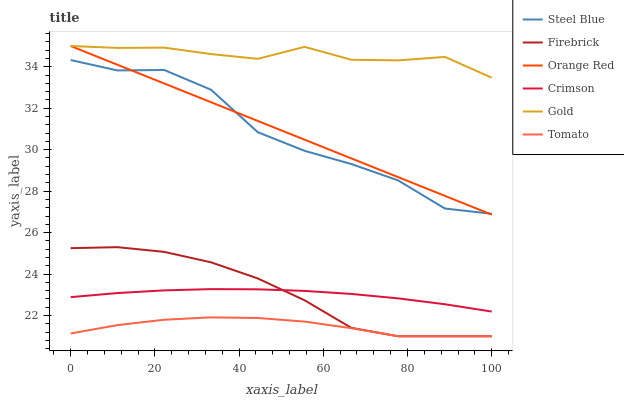Does Firebrick have the minimum area under the curve?
Answer yes or no. No. Does Firebrick have the maximum area under the curve?
Answer yes or no. No. Is Gold the smoothest?
Answer yes or no. No. Is Gold the roughest?
Answer yes or no. No. Does Gold have the lowest value?
Answer yes or no. No. Does Firebrick have the highest value?
Answer yes or no. No. Is Crimson less than Gold?
Answer yes or no. Yes. Is Steel Blue greater than Firebrick?
Answer yes or no. Yes. Does Crimson intersect Gold?
Answer yes or no. No. 